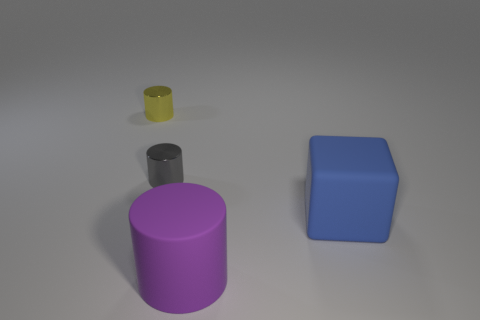Is the blue object the same size as the gray shiny cylinder?
Provide a succinct answer. No. How many other objects are there of the same shape as the gray shiny object?
Offer a very short reply. 2. The thing that is to the right of the object in front of the blue matte block is made of what material?
Provide a succinct answer. Rubber. There is a purple cylinder; are there any gray metallic cylinders to the left of it?
Provide a succinct answer. Yes. There is a purple cylinder; does it have the same size as the metallic cylinder in front of the tiny yellow metallic object?
Give a very brief answer. No. What is the size of the purple rubber object that is the same shape as the yellow metallic thing?
Your answer should be compact. Large. There is a yellow metallic object left of the gray cylinder; does it have the same size as the rubber object that is behind the large purple rubber object?
Ensure brevity in your answer.  No. What number of big things are yellow things or blue metal balls?
Give a very brief answer. 0. What number of things are on the right side of the tiny yellow shiny cylinder and behind the rubber cube?
Offer a terse response. 1. Is the yellow object made of the same material as the cylinder in front of the cube?
Your response must be concise. No. 